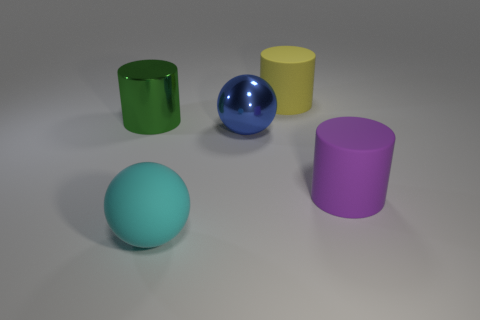Subtract all big metallic cylinders. How many cylinders are left? 2 Add 1 small purple shiny cylinders. How many objects exist? 6 Subtract all balls. How many objects are left? 3 Subtract all gray cylinders. Subtract all red cubes. How many cylinders are left? 3 Add 4 big cyan rubber things. How many big cyan rubber things exist? 5 Subtract 0 brown cylinders. How many objects are left? 5 Subtract all large rubber spheres. Subtract all large cyan objects. How many objects are left? 3 Add 2 cylinders. How many cylinders are left? 5 